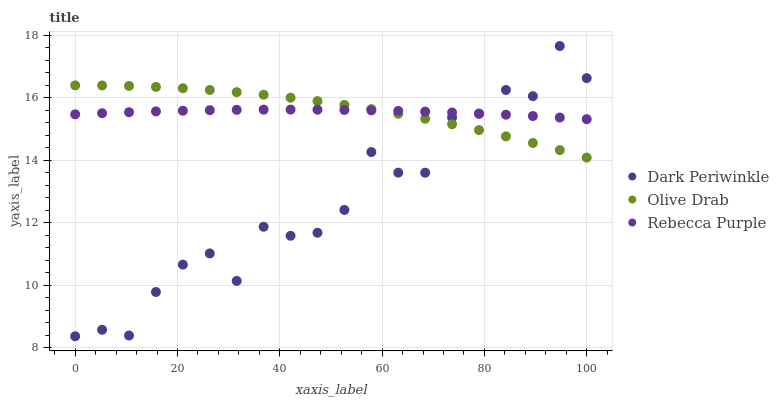Does Dark Periwinkle have the minimum area under the curve?
Answer yes or no. Yes. Does Olive Drab have the maximum area under the curve?
Answer yes or no. Yes. Does Rebecca Purple have the minimum area under the curve?
Answer yes or no. No. Does Rebecca Purple have the maximum area under the curve?
Answer yes or no. No. Is Rebecca Purple the smoothest?
Answer yes or no. Yes. Is Dark Periwinkle the roughest?
Answer yes or no. Yes. Is Olive Drab the smoothest?
Answer yes or no. No. Is Olive Drab the roughest?
Answer yes or no. No. Does Dark Periwinkle have the lowest value?
Answer yes or no. Yes. Does Olive Drab have the lowest value?
Answer yes or no. No. Does Dark Periwinkle have the highest value?
Answer yes or no. Yes. Does Olive Drab have the highest value?
Answer yes or no. No. Does Rebecca Purple intersect Dark Periwinkle?
Answer yes or no. Yes. Is Rebecca Purple less than Dark Periwinkle?
Answer yes or no. No. Is Rebecca Purple greater than Dark Periwinkle?
Answer yes or no. No. 